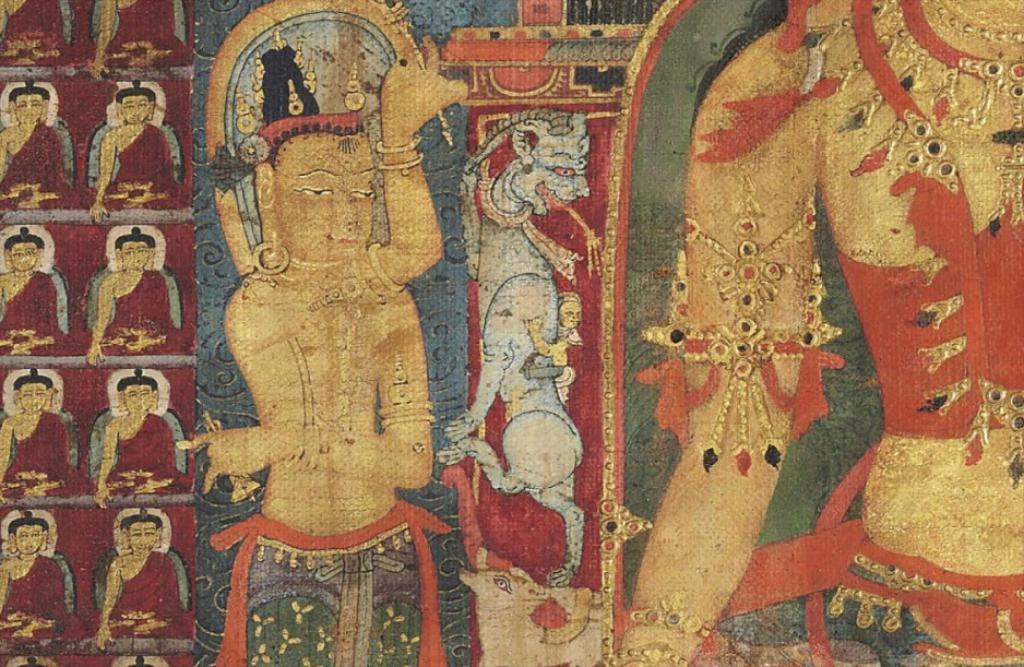What is present on the wall in the image? There is some painting and art on the wall. Can you describe the painting or art on the wall? Unfortunately, the specific details of the painting or art cannot be determined from the provided facts. What type of wall is visible in the image? The facts only mention that there is a wall in the image, but no specific details about the wall are provided. What type of creature can be seen interacting with the painting on the wall in the image? There is no creature present in the image, and the painting or art on the wall cannot be described in detail based on the provided facts. Can you tell me how many bears are depicted in the painting on the wall in the image? There is no information about bears or any other specific elements in the painting or art on the wall, as the provided facts only mention that there is some painting and art on the wall. 